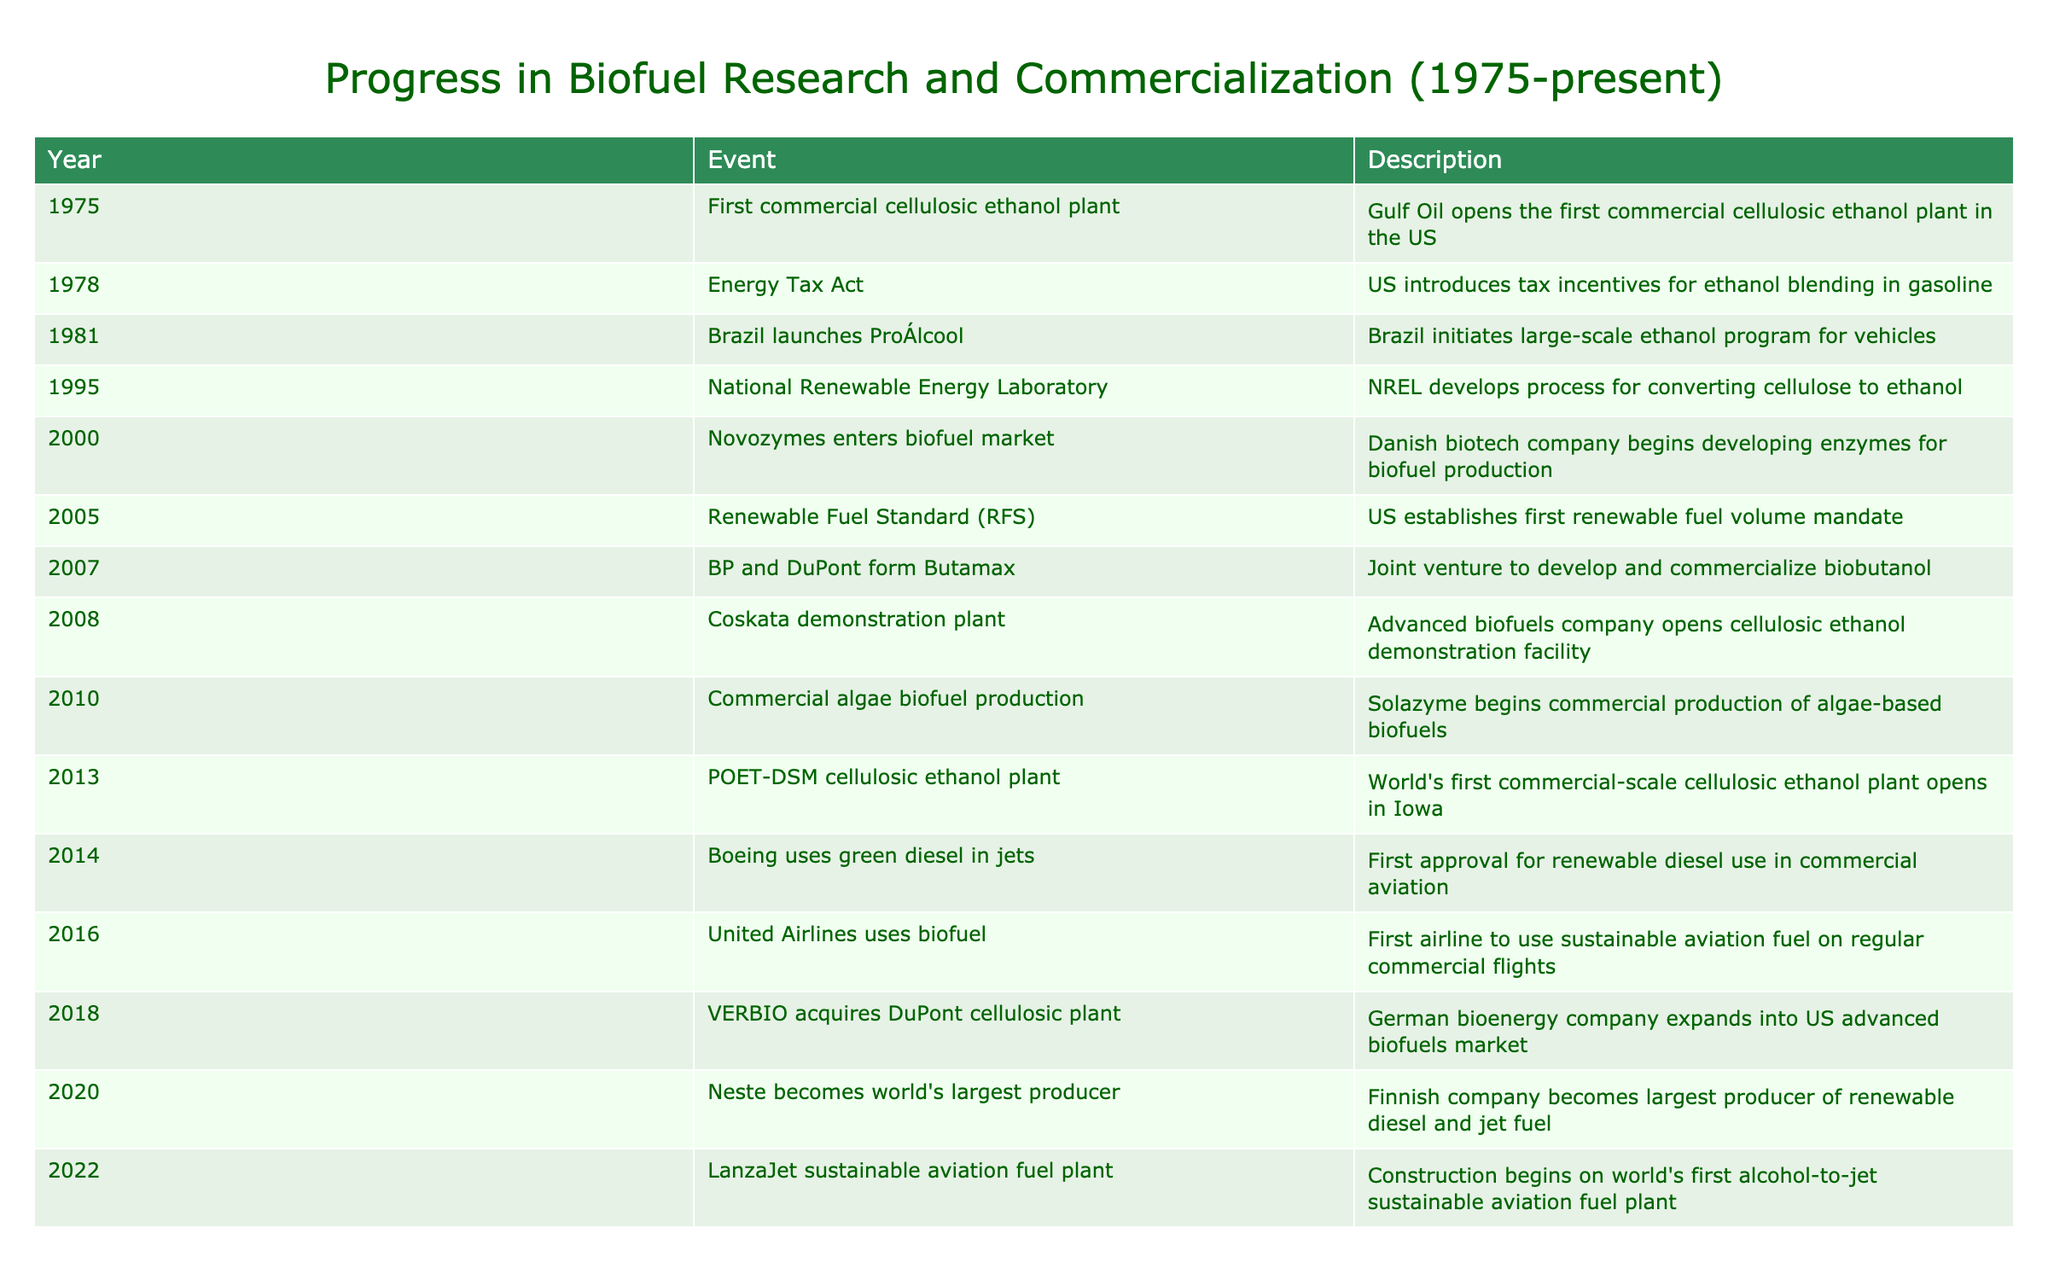What year did Brazil launch its large-scale ethanol program? According to the table, Brazil initiated its large-scale ethanol program for vehicles in 1981.
Answer: 1981 Which company developed a process for converting cellulose to ethanol in 1995? The National Renewable Energy Laboratory (NREL) is the organization that developed this process in 1995, as listed in the table.
Answer: National Renewable Energy Laboratory In what year was the first commercial-scale cellulosic ethanol plant opened, and where? The table indicates that the world's first commercial-scale cellulosic ethanol plant opened in Iowa in 2013.
Answer: 2013, Iowa Did Boeing use any green diesel in jets before 2014? The table shows that Boeing was the first to use green diesel in commercial aviation in 2014, which means they did not use it before that year.
Answer: No What is the difference in years between the opening of the first commercial cellulosic ethanol plant and the establishment of the Renewable Fuel Standard? The first commercial cellulosic ethanol plant opened in 1975 and the Renewable Fuel Standard was established in 2005. To find the difference, we subtract 1975 from 2005, yielding 30 years.
Answer: 30 years How many events related to biofuel commercialization occurred between 2000 and 2010? Based on the table, there are five events listed between these years: Novozymes entering the market (2000), the Renewable Fuel Standard (2005), BP and DuPont forming Butamax (2007), Coskata opening a demo plant (2008), and commercial algae biofuel production beginning (2010). Thus, the total is five events.
Answer: 5 events Was the first sustainable aviation fuel used by United Airlines? Yes, according to the table, United Airlines is noted as the first airline to use sustainable aviation fuel on a regular basis in 2016.
Answer: Yes Which company became the largest producer of renewable diesel and jet fuel in 2020? The table reveals that Neste, a Finnish company, became recognized as the largest producer of these fuels in 2020.
Answer: Neste What major development took place in 2022 regarding sustainable aviation fuel? The table states that in 2022, construction began on the world's first alcohol-to-jet sustainable aviation fuel plant. This marks a significant advancement in biofuel technology.
Answer: Construction of alcohol-to-jet plant began 